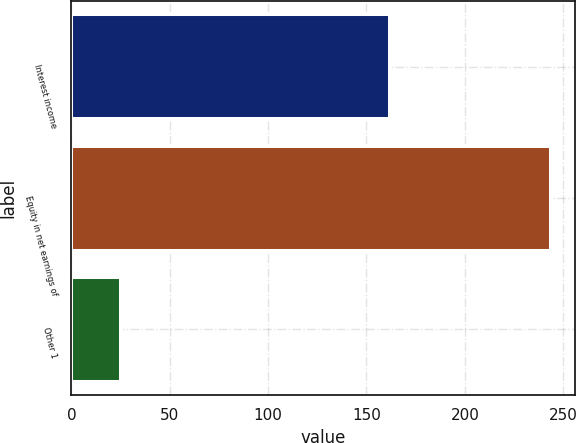Convert chart to OTSL. <chart><loc_0><loc_0><loc_500><loc_500><bar_chart><fcel>Interest income<fcel>Equity in net earnings of<fcel>Other 1<nl><fcel>162<fcel>244<fcel>25<nl></chart> 